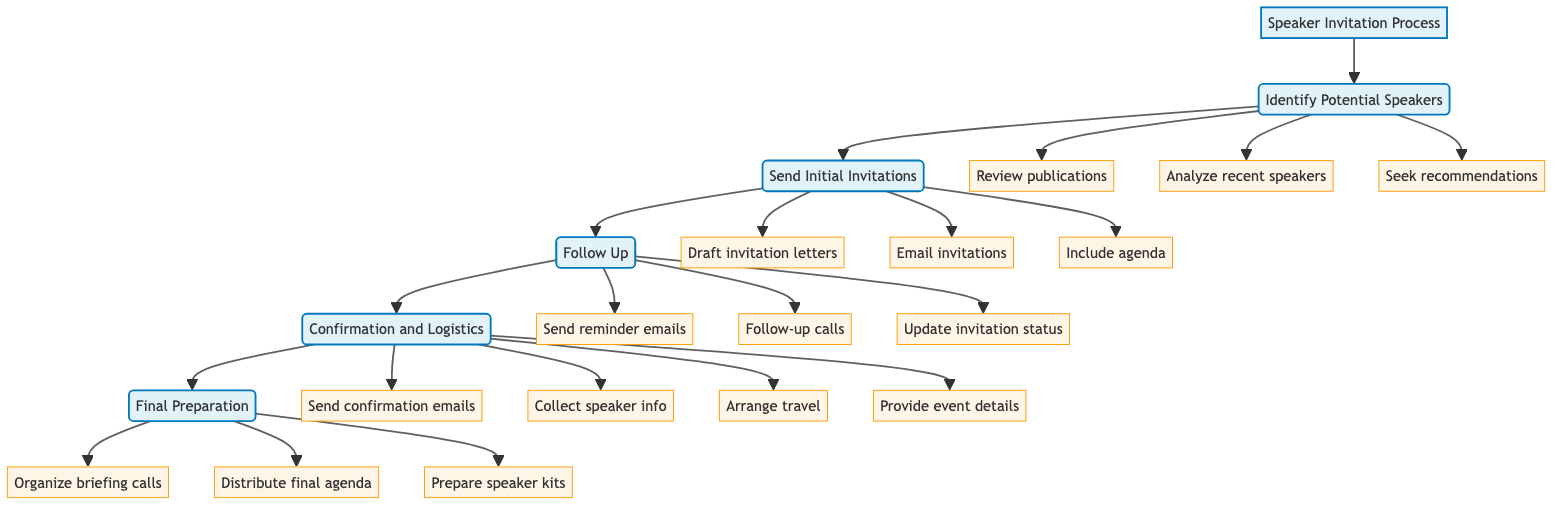What is the first task in the Speaker Invitation Process? The diagram shows that "Identify Potential Speakers" is the first task that follows "Speaker Invitation Process." It is directly connected to the main process.
Answer: Identify Potential Speakers How many subtasks are involved in the "Follow Up" phase? The diagram indicates that "Follow Up" has three subtasks: send reminder emails, follow-up calls, and update invitation status. Thus, when counting them, we determine there are three subtasks.
Answer: 3 What is the last step in the Speaker Invitation Process? According to the flowchart, the last step that follows "Confirmation and Logistics" is "Final Preparation." This is how the process concludes.
Answer: Final Preparation Which task involves arranging travel for the speakers? The "Confirmation and Logistics" task includes arranging travel as one of its subtasks, indicating the logistical coordination required after confirming speakers.
Answer: Arrange travel What task directly follows the "Send Initial Invitations" phase? A review of the flowchart shows that "Follow Up" is the task that follows "Send Initial Invitations," implying the next step involves managing responses to the invitations.
Answer: Follow Up Which two tasks have their own subtasks listed in the diagram? The tasks "Identify Potential Speakers" and "Confirmation and Logistics" are both followed by their respective subtasks as indicated by their branching in the flowchart.
Answer: Identify Potential Speakers, Confirmation and Logistics How many main tasks are in the Speaker Invitation Process? There are five main tasks outlined in the flowchart: Identify Potential Speakers, Send Initial Invitations, Follow Up, Confirmation and Logistics, and Final Preparation. Counting them gives us five main tasks.
Answer: 5 What is the primary focus of the "Final Preparation" task? The primary focus is to ensure speaker readiness by organizing briefing calls, distributing the final agenda, and preparing speaker kits, as shown in the associated subtasks.
Answer: Ensure speaker readiness What action is taken after a week of no response in the Follow Up phase? The task in the Follow Up phase specifies that reminder emails are sent after one week of no responses, hence this is the planned action in case of no reply.
Answer: Send reminder emails 